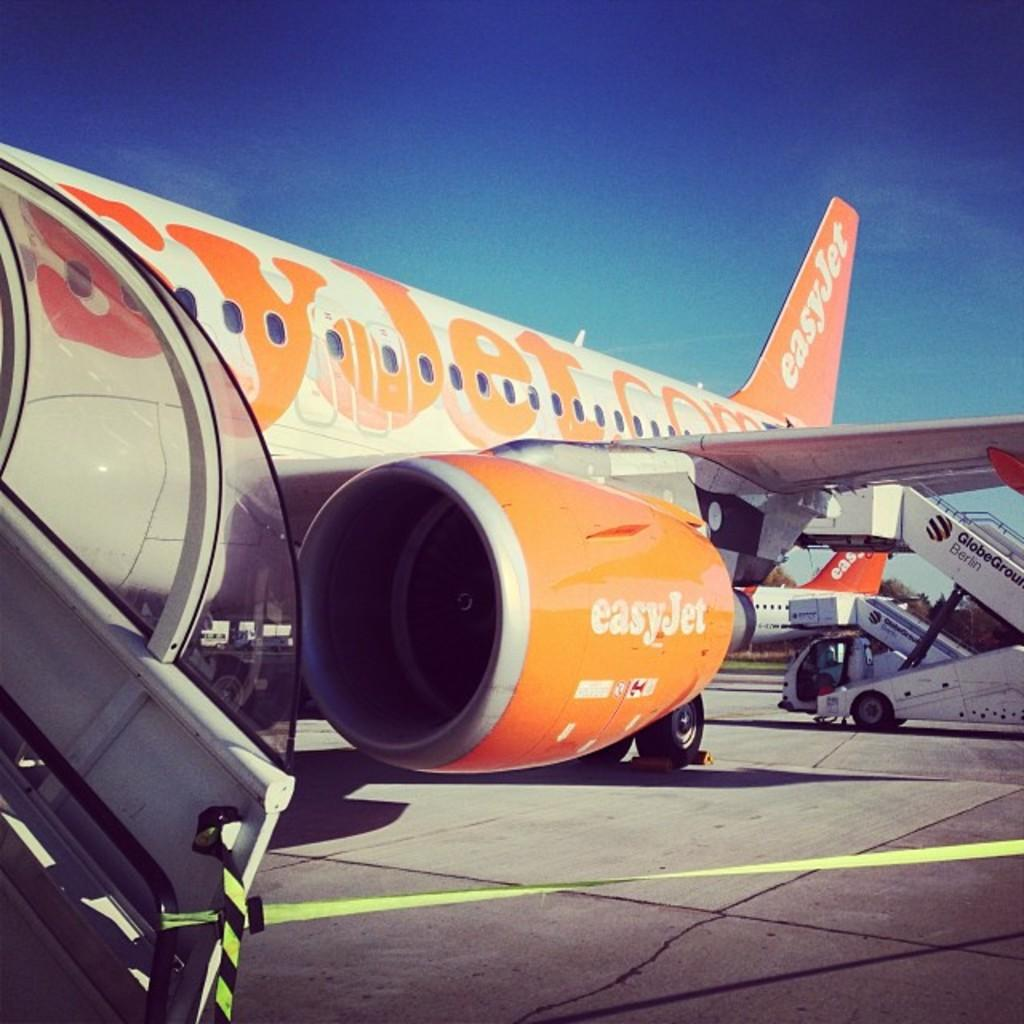<image>
Render a clear and concise summary of the photo. An Easyjet plane sits on a runway with the door open 